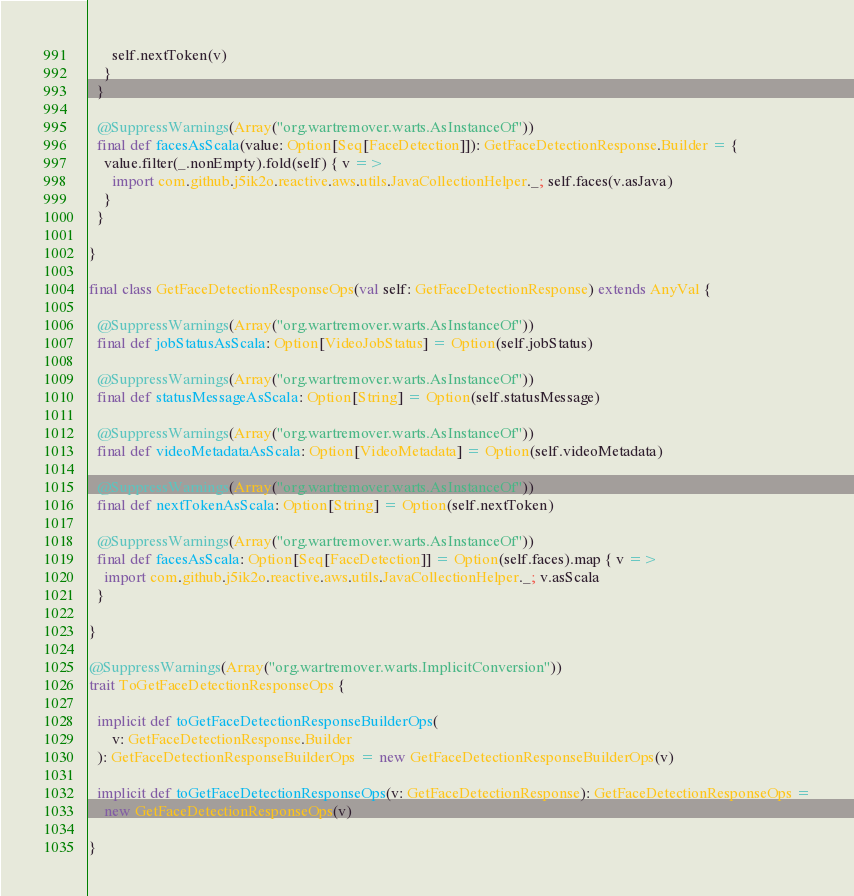Convert code to text. <code><loc_0><loc_0><loc_500><loc_500><_Scala_>      self.nextToken(v)
    }
  }

  @SuppressWarnings(Array("org.wartremover.warts.AsInstanceOf"))
  final def facesAsScala(value: Option[Seq[FaceDetection]]): GetFaceDetectionResponse.Builder = {
    value.filter(_.nonEmpty).fold(self) { v =>
      import com.github.j5ik2o.reactive.aws.utils.JavaCollectionHelper._; self.faces(v.asJava)
    }
  }

}

final class GetFaceDetectionResponseOps(val self: GetFaceDetectionResponse) extends AnyVal {

  @SuppressWarnings(Array("org.wartremover.warts.AsInstanceOf"))
  final def jobStatusAsScala: Option[VideoJobStatus] = Option(self.jobStatus)

  @SuppressWarnings(Array("org.wartremover.warts.AsInstanceOf"))
  final def statusMessageAsScala: Option[String] = Option(self.statusMessage)

  @SuppressWarnings(Array("org.wartremover.warts.AsInstanceOf"))
  final def videoMetadataAsScala: Option[VideoMetadata] = Option(self.videoMetadata)

  @SuppressWarnings(Array("org.wartremover.warts.AsInstanceOf"))
  final def nextTokenAsScala: Option[String] = Option(self.nextToken)

  @SuppressWarnings(Array("org.wartremover.warts.AsInstanceOf"))
  final def facesAsScala: Option[Seq[FaceDetection]] = Option(self.faces).map { v =>
    import com.github.j5ik2o.reactive.aws.utils.JavaCollectionHelper._; v.asScala
  }

}

@SuppressWarnings(Array("org.wartremover.warts.ImplicitConversion"))
trait ToGetFaceDetectionResponseOps {

  implicit def toGetFaceDetectionResponseBuilderOps(
      v: GetFaceDetectionResponse.Builder
  ): GetFaceDetectionResponseBuilderOps = new GetFaceDetectionResponseBuilderOps(v)

  implicit def toGetFaceDetectionResponseOps(v: GetFaceDetectionResponse): GetFaceDetectionResponseOps =
    new GetFaceDetectionResponseOps(v)

}
</code> 